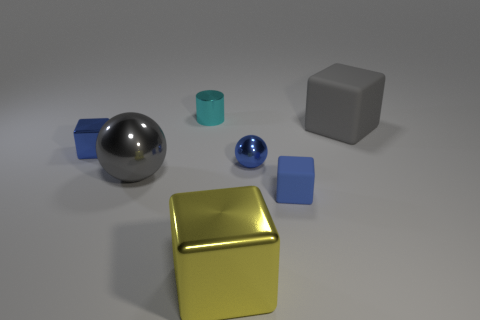Subtract all red cubes. Subtract all blue spheres. How many cubes are left? 4 Add 3 gray balls. How many objects exist? 10 Subtract all cylinders. How many objects are left? 6 Add 4 large gray objects. How many large gray objects are left? 6 Add 1 tiny metal blocks. How many tiny metal blocks exist? 2 Subtract 0 yellow cylinders. How many objects are left? 7 Subtract all tiny cyan shiny cylinders. Subtract all big shiny objects. How many objects are left? 4 